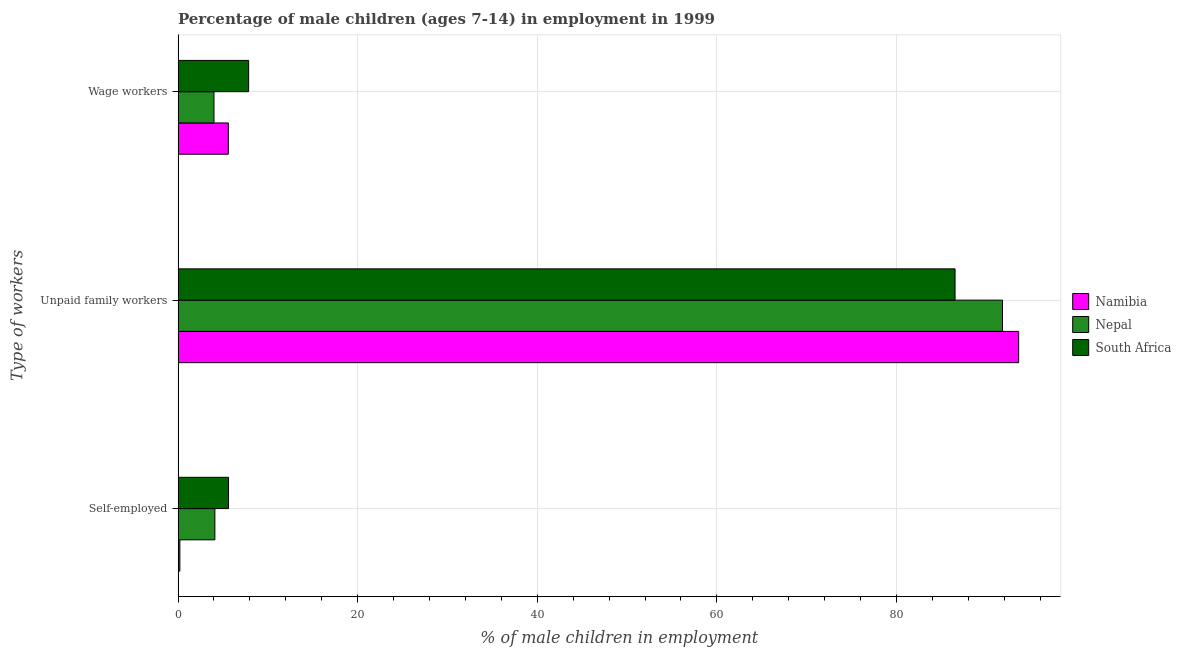How many groups of bars are there?
Make the answer very short. 3. Are the number of bars per tick equal to the number of legend labels?
Offer a terse response. Yes. Are the number of bars on each tick of the Y-axis equal?
Ensure brevity in your answer.  Yes. How many bars are there on the 1st tick from the top?
Your response must be concise. 3. What is the label of the 3rd group of bars from the top?
Give a very brief answer. Self-employed. What is the percentage of self employed children in South Africa?
Your answer should be very brief. 5.62. Across all countries, what is the maximum percentage of children employed as unpaid family workers?
Your answer should be compact. 93.6. Across all countries, what is the minimum percentage of children employed as wage workers?
Your answer should be very brief. 4. In which country was the percentage of self employed children maximum?
Offer a terse response. South Africa. In which country was the percentage of self employed children minimum?
Your response must be concise. Namibia. What is the total percentage of self employed children in the graph?
Keep it short and to the point. 9.92. What is the difference between the percentage of children employed as wage workers in South Africa and that in Nepal?
Make the answer very short. 3.86. What is the difference between the percentage of children employed as unpaid family workers in South Africa and the percentage of children employed as wage workers in Namibia?
Give a very brief answer. 80.92. What is the average percentage of children employed as wage workers per country?
Offer a very short reply. 5.82. What is the difference between the percentage of self employed children and percentage of children employed as unpaid family workers in South Africa?
Keep it short and to the point. -80.9. What is the ratio of the percentage of self employed children in Namibia to that in Nepal?
Keep it short and to the point. 0.05. Is the percentage of children employed as wage workers in Namibia less than that in Nepal?
Your response must be concise. No. Is the difference between the percentage of children employed as wage workers in South Africa and Namibia greater than the difference between the percentage of self employed children in South Africa and Namibia?
Your answer should be very brief. No. What is the difference between the highest and the second highest percentage of children employed as unpaid family workers?
Provide a succinct answer. 1.8. What is the difference between the highest and the lowest percentage of self employed children?
Your answer should be compact. 5.42. In how many countries, is the percentage of self employed children greater than the average percentage of self employed children taken over all countries?
Ensure brevity in your answer.  2. Is the sum of the percentage of self employed children in Namibia and South Africa greater than the maximum percentage of children employed as wage workers across all countries?
Ensure brevity in your answer.  No. What does the 1st bar from the top in Wage workers represents?
Your answer should be compact. South Africa. What does the 2nd bar from the bottom in Unpaid family workers represents?
Provide a succinct answer. Nepal. How many bars are there?
Provide a succinct answer. 9. Are all the bars in the graph horizontal?
Your answer should be compact. Yes. Are the values on the major ticks of X-axis written in scientific E-notation?
Provide a succinct answer. No. Does the graph contain any zero values?
Make the answer very short. No. Does the graph contain grids?
Provide a succinct answer. Yes. How many legend labels are there?
Your response must be concise. 3. What is the title of the graph?
Provide a short and direct response. Percentage of male children (ages 7-14) in employment in 1999. What is the label or title of the X-axis?
Your answer should be very brief. % of male children in employment. What is the label or title of the Y-axis?
Your response must be concise. Type of workers. What is the % of male children in employment of Namibia in Self-employed?
Offer a very short reply. 0.2. What is the % of male children in employment in Nepal in Self-employed?
Your answer should be compact. 4.1. What is the % of male children in employment in South Africa in Self-employed?
Offer a terse response. 5.62. What is the % of male children in employment of Namibia in Unpaid family workers?
Your response must be concise. 93.6. What is the % of male children in employment of Nepal in Unpaid family workers?
Provide a succinct answer. 91.8. What is the % of male children in employment in South Africa in Unpaid family workers?
Make the answer very short. 86.52. What is the % of male children in employment in South Africa in Wage workers?
Make the answer very short. 7.86. Across all Type of workers, what is the maximum % of male children in employment in Namibia?
Your answer should be very brief. 93.6. Across all Type of workers, what is the maximum % of male children in employment of Nepal?
Give a very brief answer. 91.8. Across all Type of workers, what is the maximum % of male children in employment of South Africa?
Offer a terse response. 86.52. Across all Type of workers, what is the minimum % of male children in employment of Nepal?
Offer a terse response. 4. Across all Type of workers, what is the minimum % of male children in employment of South Africa?
Provide a short and direct response. 5.62. What is the total % of male children in employment of Namibia in the graph?
Provide a short and direct response. 99.4. What is the total % of male children in employment of Nepal in the graph?
Keep it short and to the point. 99.9. What is the total % of male children in employment of South Africa in the graph?
Your answer should be compact. 100. What is the difference between the % of male children in employment in Namibia in Self-employed and that in Unpaid family workers?
Provide a succinct answer. -93.4. What is the difference between the % of male children in employment of Nepal in Self-employed and that in Unpaid family workers?
Your answer should be very brief. -87.7. What is the difference between the % of male children in employment in South Africa in Self-employed and that in Unpaid family workers?
Offer a very short reply. -80.9. What is the difference between the % of male children in employment of Nepal in Self-employed and that in Wage workers?
Provide a short and direct response. 0.1. What is the difference between the % of male children in employment of South Africa in Self-employed and that in Wage workers?
Your answer should be very brief. -2.24. What is the difference between the % of male children in employment of Namibia in Unpaid family workers and that in Wage workers?
Offer a terse response. 88. What is the difference between the % of male children in employment in Nepal in Unpaid family workers and that in Wage workers?
Offer a very short reply. 87.8. What is the difference between the % of male children in employment in South Africa in Unpaid family workers and that in Wage workers?
Offer a terse response. 78.66. What is the difference between the % of male children in employment of Namibia in Self-employed and the % of male children in employment of Nepal in Unpaid family workers?
Your answer should be compact. -91.6. What is the difference between the % of male children in employment of Namibia in Self-employed and the % of male children in employment of South Africa in Unpaid family workers?
Provide a succinct answer. -86.32. What is the difference between the % of male children in employment of Nepal in Self-employed and the % of male children in employment of South Africa in Unpaid family workers?
Ensure brevity in your answer.  -82.42. What is the difference between the % of male children in employment in Namibia in Self-employed and the % of male children in employment in South Africa in Wage workers?
Make the answer very short. -7.66. What is the difference between the % of male children in employment in Nepal in Self-employed and the % of male children in employment in South Africa in Wage workers?
Ensure brevity in your answer.  -3.76. What is the difference between the % of male children in employment of Namibia in Unpaid family workers and the % of male children in employment of Nepal in Wage workers?
Provide a short and direct response. 89.6. What is the difference between the % of male children in employment in Namibia in Unpaid family workers and the % of male children in employment in South Africa in Wage workers?
Give a very brief answer. 85.74. What is the difference between the % of male children in employment of Nepal in Unpaid family workers and the % of male children in employment of South Africa in Wage workers?
Ensure brevity in your answer.  83.94. What is the average % of male children in employment in Namibia per Type of workers?
Provide a short and direct response. 33.13. What is the average % of male children in employment of Nepal per Type of workers?
Offer a very short reply. 33.3. What is the average % of male children in employment in South Africa per Type of workers?
Your response must be concise. 33.33. What is the difference between the % of male children in employment in Namibia and % of male children in employment in Nepal in Self-employed?
Ensure brevity in your answer.  -3.9. What is the difference between the % of male children in employment in Namibia and % of male children in employment in South Africa in Self-employed?
Your answer should be compact. -5.42. What is the difference between the % of male children in employment in Nepal and % of male children in employment in South Africa in Self-employed?
Your answer should be very brief. -1.52. What is the difference between the % of male children in employment in Namibia and % of male children in employment in Nepal in Unpaid family workers?
Your answer should be very brief. 1.8. What is the difference between the % of male children in employment in Namibia and % of male children in employment in South Africa in Unpaid family workers?
Offer a very short reply. 7.08. What is the difference between the % of male children in employment of Nepal and % of male children in employment of South Africa in Unpaid family workers?
Make the answer very short. 5.28. What is the difference between the % of male children in employment in Namibia and % of male children in employment in Nepal in Wage workers?
Your response must be concise. 1.6. What is the difference between the % of male children in employment of Namibia and % of male children in employment of South Africa in Wage workers?
Offer a terse response. -2.26. What is the difference between the % of male children in employment of Nepal and % of male children in employment of South Africa in Wage workers?
Offer a terse response. -3.86. What is the ratio of the % of male children in employment of Namibia in Self-employed to that in Unpaid family workers?
Provide a short and direct response. 0. What is the ratio of the % of male children in employment of Nepal in Self-employed to that in Unpaid family workers?
Give a very brief answer. 0.04. What is the ratio of the % of male children in employment in South Africa in Self-employed to that in Unpaid family workers?
Ensure brevity in your answer.  0.07. What is the ratio of the % of male children in employment of Namibia in Self-employed to that in Wage workers?
Your response must be concise. 0.04. What is the ratio of the % of male children in employment in South Africa in Self-employed to that in Wage workers?
Provide a succinct answer. 0.71. What is the ratio of the % of male children in employment of Namibia in Unpaid family workers to that in Wage workers?
Offer a very short reply. 16.71. What is the ratio of the % of male children in employment of Nepal in Unpaid family workers to that in Wage workers?
Ensure brevity in your answer.  22.95. What is the ratio of the % of male children in employment of South Africa in Unpaid family workers to that in Wage workers?
Offer a terse response. 11.01. What is the difference between the highest and the second highest % of male children in employment in Nepal?
Provide a short and direct response. 87.7. What is the difference between the highest and the second highest % of male children in employment of South Africa?
Offer a very short reply. 78.66. What is the difference between the highest and the lowest % of male children in employment of Namibia?
Your answer should be very brief. 93.4. What is the difference between the highest and the lowest % of male children in employment of Nepal?
Keep it short and to the point. 87.8. What is the difference between the highest and the lowest % of male children in employment in South Africa?
Offer a terse response. 80.9. 